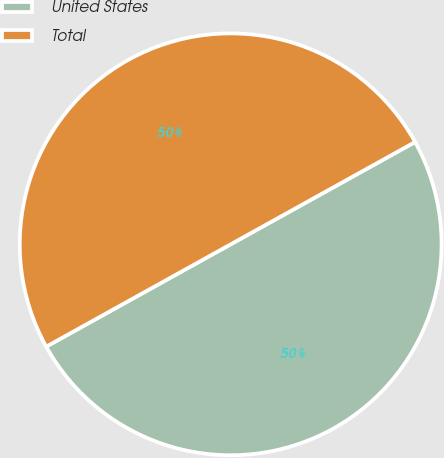<chart> <loc_0><loc_0><loc_500><loc_500><pie_chart><fcel>United States<fcel>Total<nl><fcel>50.0%<fcel>50.0%<nl></chart> 